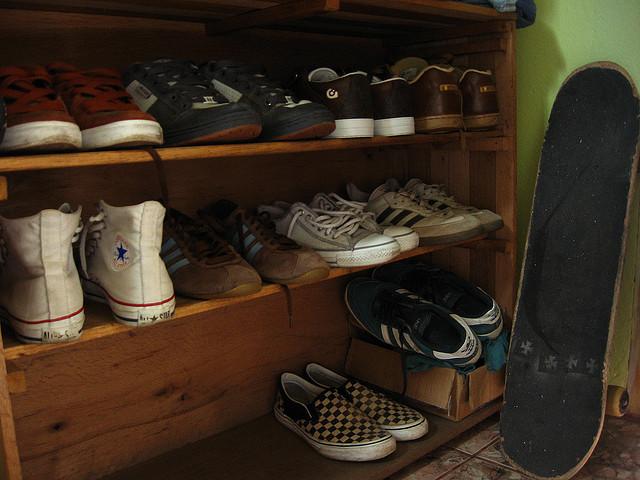How many shoes are on the shelf?
Be succinct. 20. What type of shoes are depicted?
Keep it brief. Sneakers. What color is the skateboard?
Concise answer only. Black. 